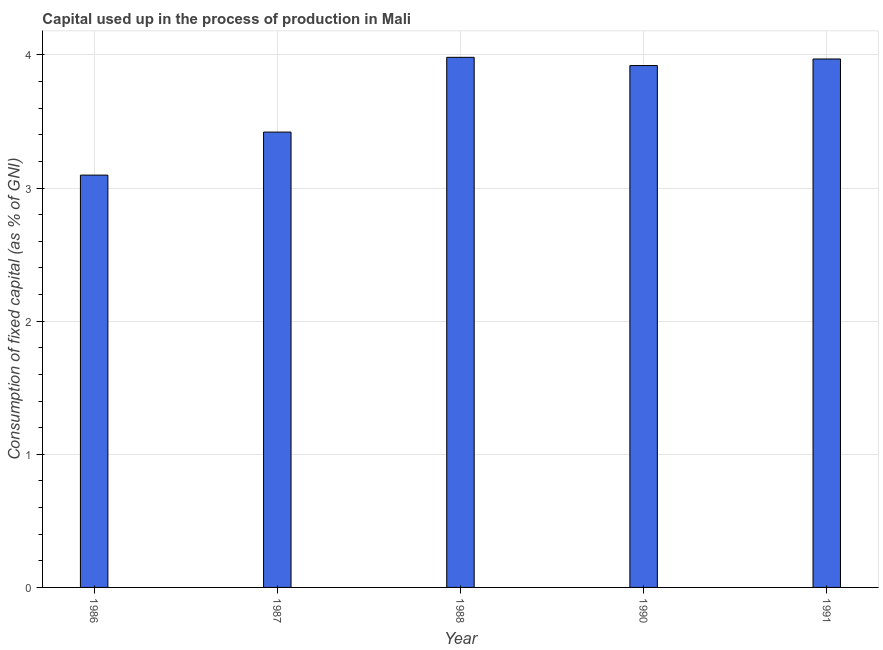Does the graph contain grids?
Provide a short and direct response. Yes. What is the title of the graph?
Make the answer very short. Capital used up in the process of production in Mali. What is the label or title of the Y-axis?
Ensure brevity in your answer.  Consumption of fixed capital (as % of GNI). What is the consumption of fixed capital in 1986?
Provide a short and direct response. 3.1. Across all years, what is the maximum consumption of fixed capital?
Offer a very short reply. 3.98. Across all years, what is the minimum consumption of fixed capital?
Offer a terse response. 3.1. In which year was the consumption of fixed capital minimum?
Give a very brief answer. 1986. What is the sum of the consumption of fixed capital?
Make the answer very short. 18.39. What is the difference between the consumption of fixed capital in 1988 and 1991?
Offer a terse response. 0.01. What is the average consumption of fixed capital per year?
Ensure brevity in your answer.  3.68. What is the median consumption of fixed capital?
Your response must be concise. 3.92. In how many years, is the consumption of fixed capital greater than 1 %?
Provide a short and direct response. 5. What is the ratio of the consumption of fixed capital in 1987 to that in 1990?
Your answer should be very brief. 0.87. What is the difference between the highest and the second highest consumption of fixed capital?
Offer a terse response. 0.01. What is the difference between the highest and the lowest consumption of fixed capital?
Offer a very short reply. 0.88. In how many years, is the consumption of fixed capital greater than the average consumption of fixed capital taken over all years?
Ensure brevity in your answer.  3. What is the difference between two consecutive major ticks on the Y-axis?
Make the answer very short. 1. Are the values on the major ticks of Y-axis written in scientific E-notation?
Your answer should be very brief. No. What is the Consumption of fixed capital (as % of GNI) in 1986?
Your answer should be very brief. 3.1. What is the Consumption of fixed capital (as % of GNI) in 1987?
Make the answer very short. 3.42. What is the Consumption of fixed capital (as % of GNI) in 1988?
Offer a terse response. 3.98. What is the Consumption of fixed capital (as % of GNI) of 1990?
Provide a succinct answer. 3.92. What is the Consumption of fixed capital (as % of GNI) in 1991?
Provide a succinct answer. 3.97. What is the difference between the Consumption of fixed capital (as % of GNI) in 1986 and 1987?
Provide a short and direct response. -0.32. What is the difference between the Consumption of fixed capital (as % of GNI) in 1986 and 1988?
Your answer should be very brief. -0.88. What is the difference between the Consumption of fixed capital (as % of GNI) in 1986 and 1990?
Ensure brevity in your answer.  -0.82. What is the difference between the Consumption of fixed capital (as % of GNI) in 1986 and 1991?
Your answer should be very brief. -0.87. What is the difference between the Consumption of fixed capital (as % of GNI) in 1987 and 1988?
Provide a succinct answer. -0.56. What is the difference between the Consumption of fixed capital (as % of GNI) in 1987 and 1990?
Provide a short and direct response. -0.5. What is the difference between the Consumption of fixed capital (as % of GNI) in 1987 and 1991?
Your answer should be compact. -0.55. What is the difference between the Consumption of fixed capital (as % of GNI) in 1988 and 1990?
Offer a very short reply. 0.06. What is the difference between the Consumption of fixed capital (as % of GNI) in 1988 and 1991?
Keep it short and to the point. 0.01. What is the difference between the Consumption of fixed capital (as % of GNI) in 1990 and 1991?
Make the answer very short. -0.05. What is the ratio of the Consumption of fixed capital (as % of GNI) in 1986 to that in 1987?
Your answer should be very brief. 0.91. What is the ratio of the Consumption of fixed capital (as % of GNI) in 1986 to that in 1988?
Your answer should be compact. 0.78. What is the ratio of the Consumption of fixed capital (as % of GNI) in 1986 to that in 1990?
Your response must be concise. 0.79. What is the ratio of the Consumption of fixed capital (as % of GNI) in 1986 to that in 1991?
Provide a succinct answer. 0.78. What is the ratio of the Consumption of fixed capital (as % of GNI) in 1987 to that in 1988?
Offer a very short reply. 0.86. What is the ratio of the Consumption of fixed capital (as % of GNI) in 1987 to that in 1990?
Provide a succinct answer. 0.87. What is the ratio of the Consumption of fixed capital (as % of GNI) in 1987 to that in 1991?
Your answer should be very brief. 0.86. What is the ratio of the Consumption of fixed capital (as % of GNI) in 1988 to that in 1990?
Your answer should be very brief. 1.02. What is the ratio of the Consumption of fixed capital (as % of GNI) in 1988 to that in 1991?
Your answer should be compact. 1. What is the ratio of the Consumption of fixed capital (as % of GNI) in 1990 to that in 1991?
Ensure brevity in your answer.  0.99. 